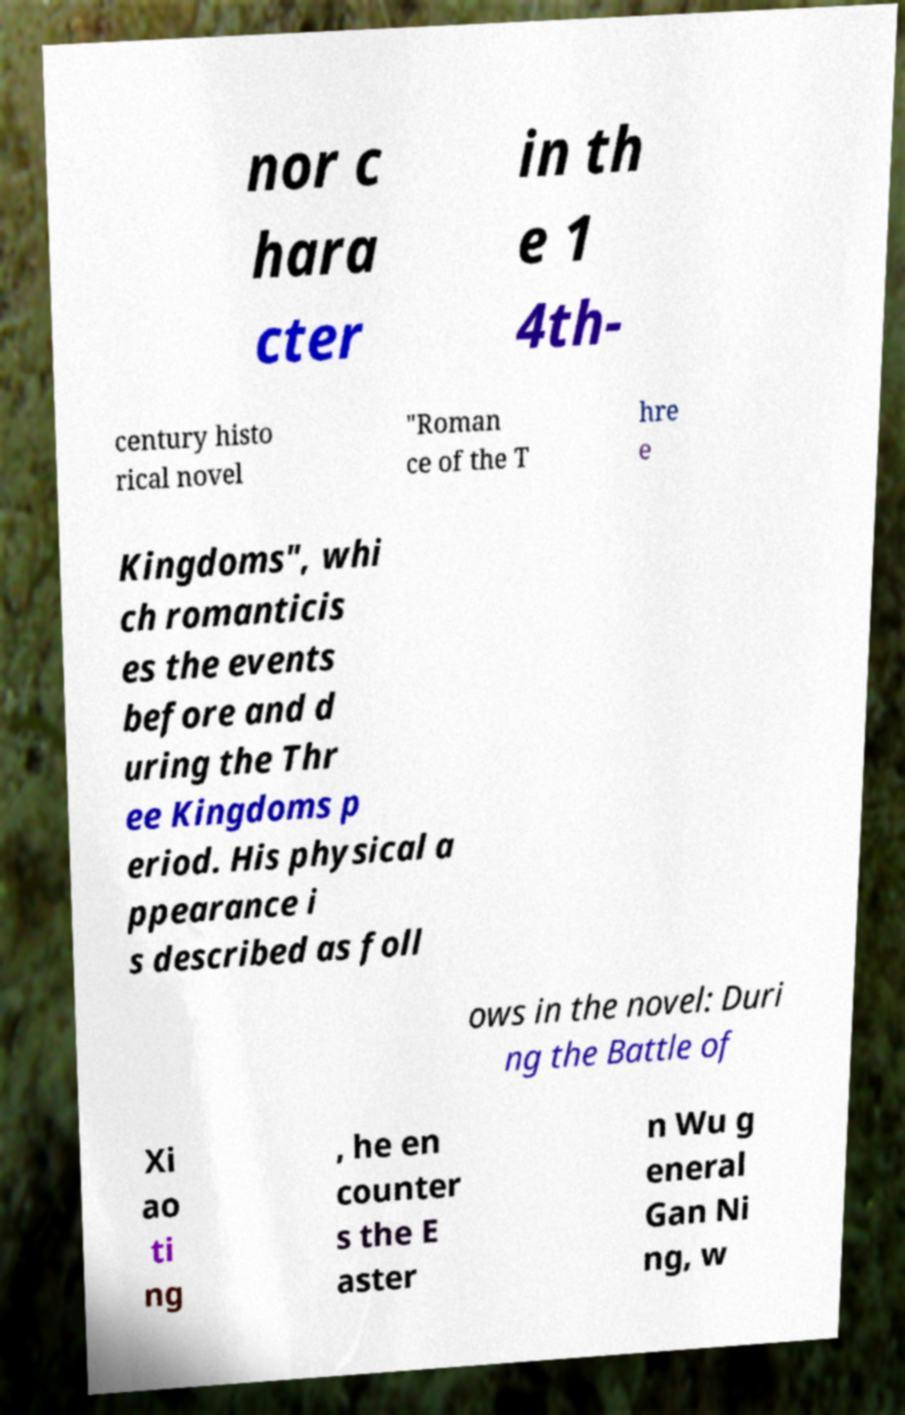I need the written content from this picture converted into text. Can you do that? nor c hara cter in th e 1 4th- century histo rical novel "Roman ce of the T hre e Kingdoms", whi ch romanticis es the events before and d uring the Thr ee Kingdoms p eriod. His physical a ppearance i s described as foll ows in the novel: Duri ng the Battle of Xi ao ti ng , he en counter s the E aster n Wu g eneral Gan Ni ng, w 